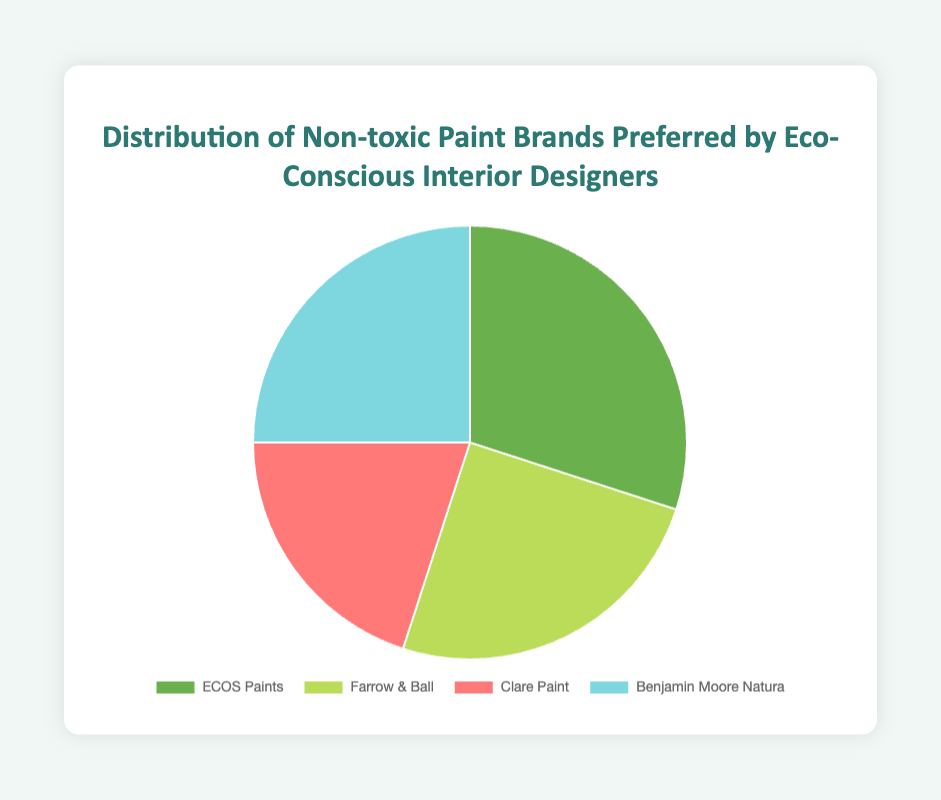What is the most preferred brand of non-toxic paint among eco-conscious interior designers? By examining the segments of the pie chart, ECOS Paints has the largest segment with a 30% share, making it the most preferred brand.
Answer: ECOS Paints Which two brands have an equal market share percentage according to the pie chart? By observing the pie chart's segments and their associated percentages, Farrow & Ball and Benjamin Moore Natura both hold a 25% share.
Answer: Farrow & Ball and Benjamin Moore Natura What is the combined market share percentage of the brands Farrow & Ball and Benjamin Moore Natura? Adding the market share percentages of Farrow & Ball (25%) and Benjamin Moore Natura (25%) gives a total of 25% + 25% = 50%.
Answer: 50% Which brand has the smallest market share among the preferred non-toxic paint brands? By looking at the smallest segment in the pie chart, Clare Paint holds the smallest share with 20%.
Answer: Clare Paint How much greater is the market share of ECOS Paints compared to Clare Paint? ECOS Paints has a market share of 30%, and Clare Paint has 20%. The difference is 30% - 20% = 10%.
Answer: 10% What is the average market share percentage of all four non-toxic paint brands? Summing the market shares: 30% (ECOS Paints) + 25% (Farrow & Ball) + 20% (Clare Paint) + 25% (Benjamin Moore Natura) = 100%. Dividing by the four brands: 100% / 4 = 25%.
Answer: 25% What portion of the pie chart is represented by non-green colors? Green colors represent ECOS Paints (30%) and Clare Paint (20%). Non-green colors are Farrow & Ball (25%) and Benjamin Moore Natura (25%). Adding these, 25% + 25% = 50%.
Answer: 50% Are there any brands with an equal share of market depicted in identical colors? By checking the pie chart’s color distinction, even though Farrow & Ball and Benjamin Moore Natura have equal shares (25%), they are depicted in different colors.
Answer: No What is the average market share percentage of the brands except for ECOS Paints? Excluding ECOS Paints (30%), the remaining brands' shares are: Farrow & Ball (25%), Clare Paint (20%), and Benjamin Moore Natura (25%). Adding these: 25% + 20% + 25% = 70%. Dividing by 3: 70% / 3 ≈ 23.33%.
Answer: 23.33% Is the sum of the market shares of Farrow & Ball and Clare Paint greater than the market share of ECOS Paints? Farrow & Ball has a 25% share and Clare Paint has 20%. Adding these: 25% + 20% = 45%, which is greater than ECOS Paints' 30%.
Answer: Yes 